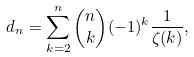<formula> <loc_0><loc_0><loc_500><loc_500>d _ { n } = \sum _ { k = 2 } ^ { n } \binom { n } { k } ( - 1 ) ^ { k } \frac { 1 } { \zeta ( k ) } ,</formula> 